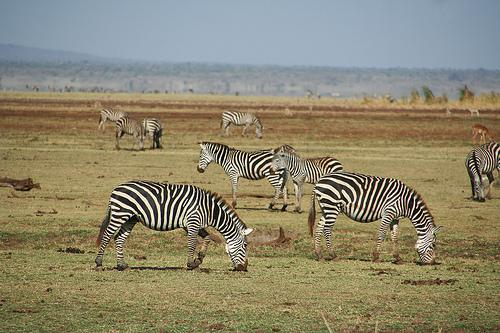Question: what animal is pictured?
Choices:
A. Elephant.
B. Kudu.
C. Giraffe.
D. Zebra.
Answer with the letter. Answer: D Question: why are the animals in the field?
Choices:
A. Sleeping.
B. Mating.
C. Eating.
D. Drinking.
Answer with the letter. Answer: C Question: who is in the photo?
Choices:
A. Giraffe.
B. Elephant.
C. Lion.
D. Zebra.
Answer with the letter. Answer: D Question: what are the zebra doing?
Choices:
A. Sleeping.
B. Eating.
C. Mating.
D. Drinking.
Answer with the letter. Answer: B Question: where is the photo taken?
Choices:
A. In field.
B. In a house.
C. In a yard.
D. On a mountain.
Answer with the letter. Answer: A 